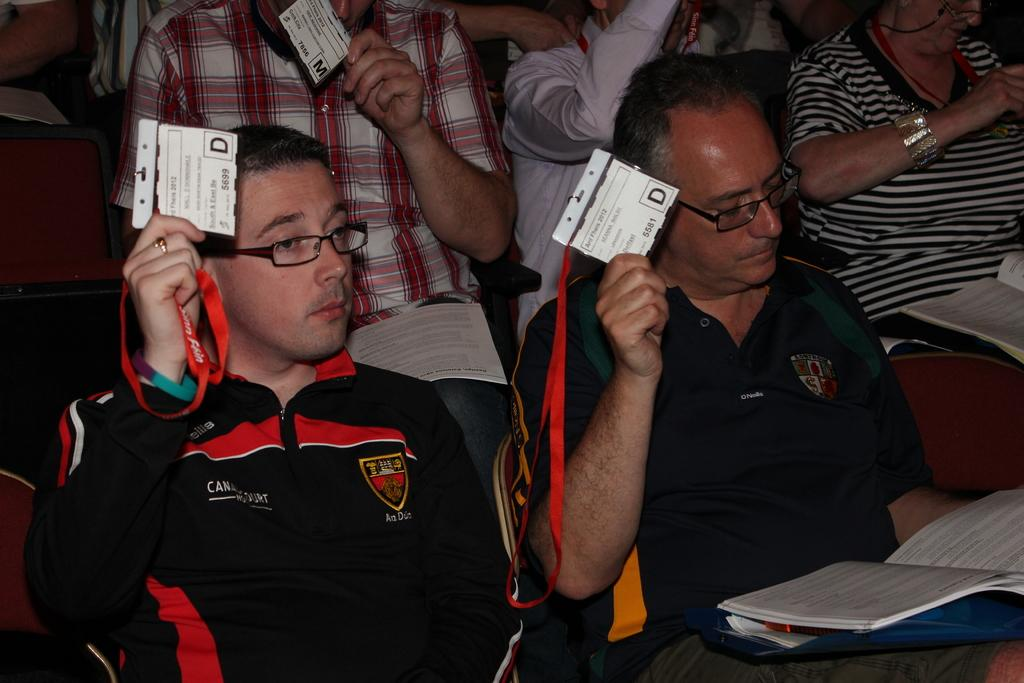What are the people in the image doing? The people in the image are sitting on chairs. What are some of the people holding in their hands? Some people are holding ID cards in their hands. Can you describe the man with the book in the image? There is a book on a man in the image. What type of door can be seen in the image? There is no door present in the image. What songs are the people singing in the image? There is no indication in the image that the people are singing songs. 